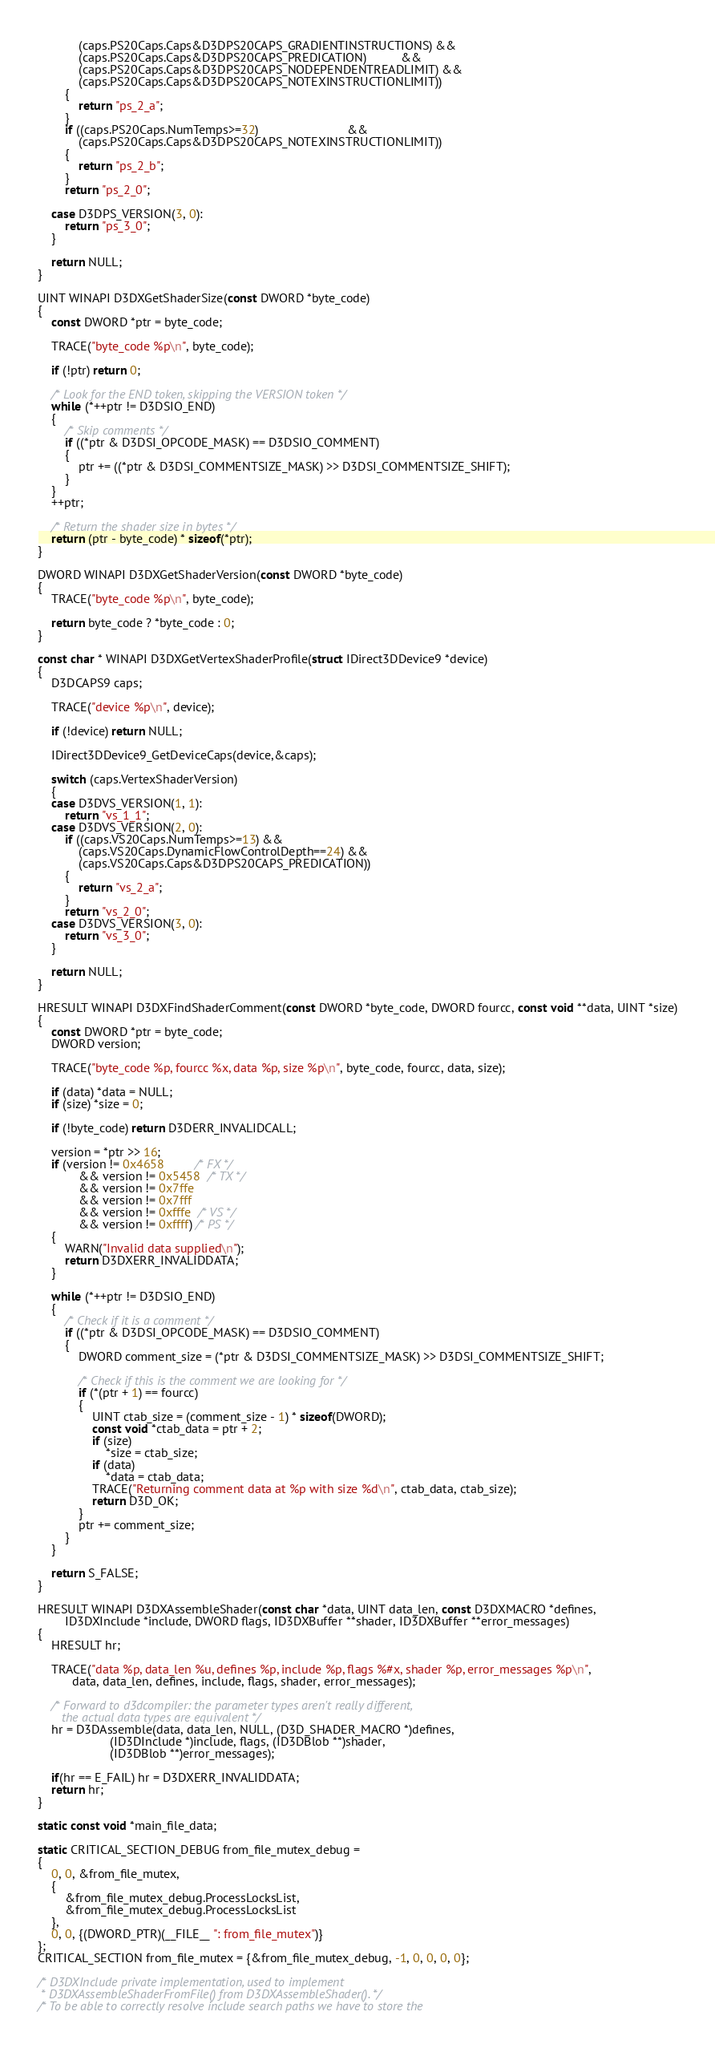Convert code to text. <code><loc_0><loc_0><loc_500><loc_500><_C_>            (caps.PS20Caps.Caps&D3DPS20CAPS_GRADIENTINSTRUCTIONS) &&
            (caps.PS20Caps.Caps&D3DPS20CAPS_PREDICATION)          &&
            (caps.PS20Caps.Caps&D3DPS20CAPS_NODEPENDENTREADLIMIT) &&
            (caps.PS20Caps.Caps&D3DPS20CAPS_NOTEXINSTRUCTIONLIMIT))
        {
            return "ps_2_a";
        }
        if ((caps.PS20Caps.NumTemps>=32)                          &&
            (caps.PS20Caps.Caps&D3DPS20CAPS_NOTEXINSTRUCTIONLIMIT))
        {
            return "ps_2_b";
        }
        return "ps_2_0";

    case D3DPS_VERSION(3, 0):
        return "ps_3_0";
    }

    return NULL;
}

UINT WINAPI D3DXGetShaderSize(const DWORD *byte_code)
{
    const DWORD *ptr = byte_code;

    TRACE("byte_code %p\n", byte_code);

    if (!ptr) return 0;

    /* Look for the END token, skipping the VERSION token */
    while (*++ptr != D3DSIO_END)
    {
        /* Skip comments */
        if ((*ptr & D3DSI_OPCODE_MASK) == D3DSIO_COMMENT)
        {
            ptr += ((*ptr & D3DSI_COMMENTSIZE_MASK) >> D3DSI_COMMENTSIZE_SHIFT);
        }
    }
    ++ptr;

    /* Return the shader size in bytes */
    return (ptr - byte_code) * sizeof(*ptr);
}

DWORD WINAPI D3DXGetShaderVersion(const DWORD *byte_code)
{
    TRACE("byte_code %p\n", byte_code);

    return byte_code ? *byte_code : 0;
}

const char * WINAPI D3DXGetVertexShaderProfile(struct IDirect3DDevice9 *device)
{
    D3DCAPS9 caps;

    TRACE("device %p\n", device);

    if (!device) return NULL;

    IDirect3DDevice9_GetDeviceCaps(device,&caps);

    switch (caps.VertexShaderVersion)
    {
    case D3DVS_VERSION(1, 1):
        return "vs_1_1";
    case D3DVS_VERSION(2, 0):
        if ((caps.VS20Caps.NumTemps>=13) &&
            (caps.VS20Caps.DynamicFlowControlDepth==24) &&
            (caps.VS20Caps.Caps&D3DPS20CAPS_PREDICATION))
        {
            return "vs_2_a";
        }
        return "vs_2_0";
    case D3DVS_VERSION(3, 0):
        return "vs_3_0";
    }

    return NULL;
}

HRESULT WINAPI D3DXFindShaderComment(const DWORD *byte_code, DWORD fourcc, const void **data, UINT *size)
{
    const DWORD *ptr = byte_code;
    DWORD version;

    TRACE("byte_code %p, fourcc %x, data %p, size %p\n", byte_code, fourcc, data, size);

    if (data) *data = NULL;
    if (size) *size = 0;

    if (!byte_code) return D3DERR_INVALIDCALL;

    version = *ptr >> 16;
    if (version != 0x4658         /* FX */
            && version != 0x5458  /* TX */
            && version != 0x7ffe
            && version != 0x7fff
            && version != 0xfffe  /* VS */
            && version != 0xffff) /* PS */
    {
        WARN("Invalid data supplied\n");
        return D3DXERR_INVALIDDATA;
    }

    while (*++ptr != D3DSIO_END)
    {
        /* Check if it is a comment */
        if ((*ptr & D3DSI_OPCODE_MASK) == D3DSIO_COMMENT)
        {
            DWORD comment_size = (*ptr & D3DSI_COMMENTSIZE_MASK) >> D3DSI_COMMENTSIZE_SHIFT;

            /* Check if this is the comment we are looking for */
            if (*(ptr + 1) == fourcc)
            {
                UINT ctab_size = (comment_size - 1) * sizeof(DWORD);
                const void *ctab_data = ptr + 2;
                if (size)
                    *size = ctab_size;
                if (data)
                    *data = ctab_data;
                TRACE("Returning comment data at %p with size %d\n", ctab_data, ctab_size);
                return D3D_OK;
            }
            ptr += comment_size;
        }
    }

    return S_FALSE;
}

HRESULT WINAPI D3DXAssembleShader(const char *data, UINT data_len, const D3DXMACRO *defines,
        ID3DXInclude *include, DWORD flags, ID3DXBuffer **shader, ID3DXBuffer **error_messages)
{
    HRESULT hr;

    TRACE("data %p, data_len %u, defines %p, include %p, flags %#x, shader %p, error_messages %p\n",
          data, data_len, defines, include, flags, shader, error_messages);

    /* Forward to d3dcompiler: the parameter types aren't really different,
       the actual data types are equivalent */
    hr = D3DAssemble(data, data_len, NULL, (D3D_SHADER_MACRO *)defines,
                     (ID3DInclude *)include, flags, (ID3DBlob **)shader,
                     (ID3DBlob **)error_messages);

    if(hr == E_FAIL) hr = D3DXERR_INVALIDDATA;
    return hr;
}

static const void *main_file_data;

static CRITICAL_SECTION_DEBUG from_file_mutex_debug =
{
    0, 0, &from_file_mutex,
    {
        &from_file_mutex_debug.ProcessLocksList,
        &from_file_mutex_debug.ProcessLocksList
    },
    0, 0, {(DWORD_PTR)(__FILE__ ": from_file_mutex")}
};
CRITICAL_SECTION from_file_mutex = {&from_file_mutex_debug, -1, 0, 0, 0, 0};

/* D3DXInclude private implementation, used to implement
 * D3DXAssembleShaderFromFile() from D3DXAssembleShader(). */
/* To be able to correctly resolve include search paths we have to store the</code> 